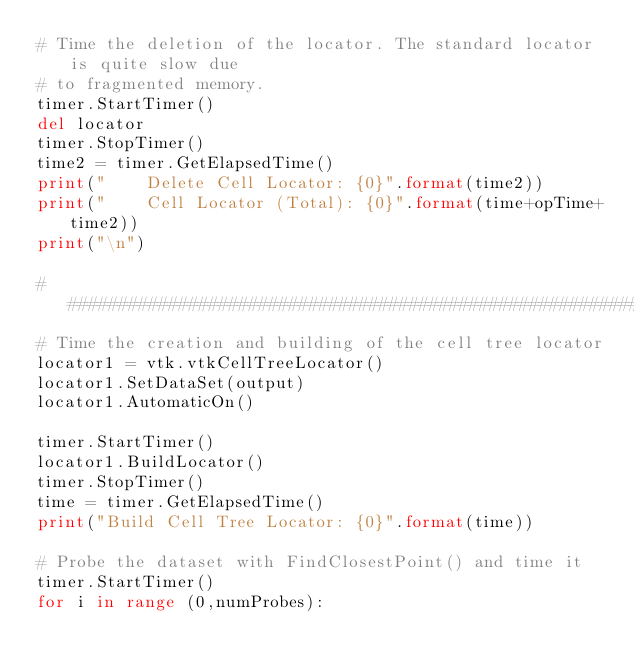Convert code to text. <code><loc_0><loc_0><loc_500><loc_500><_Python_># Time the deletion of the locator. The standard locator is quite slow due
# to fragmented memory.
timer.StartTimer()
del locator
timer.StopTimer()
time2 = timer.GetElapsedTime()
print("    Delete Cell Locator: {0}".format(time2))
print("    Cell Locator (Total): {0}".format(time+opTime+time2))
print("\n")

#############################################################
# Time the creation and building of the cell tree locator
locator1 = vtk.vtkCellTreeLocator()
locator1.SetDataSet(output)
locator1.AutomaticOn()

timer.StartTimer()
locator1.BuildLocator()
timer.StopTimer()
time = timer.GetElapsedTime()
print("Build Cell Tree Locator: {0}".format(time))

# Probe the dataset with FindClosestPoint() and time it
timer.StartTimer()
for i in range (0,numProbes):</code> 